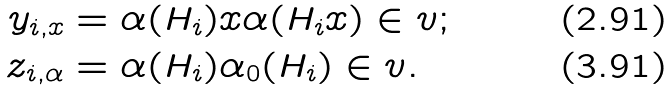<formula> <loc_0><loc_0><loc_500><loc_500>y _ { i , x } & = \alpha ( H _ { i } ) x \alpha ( H _ { i } x ) \in v ; \\ z _ { i , \alpha } & = \alpha ( H _ { i } ) \alpha _ { 0 } ( H _ { i } ) \in v .</formula> 